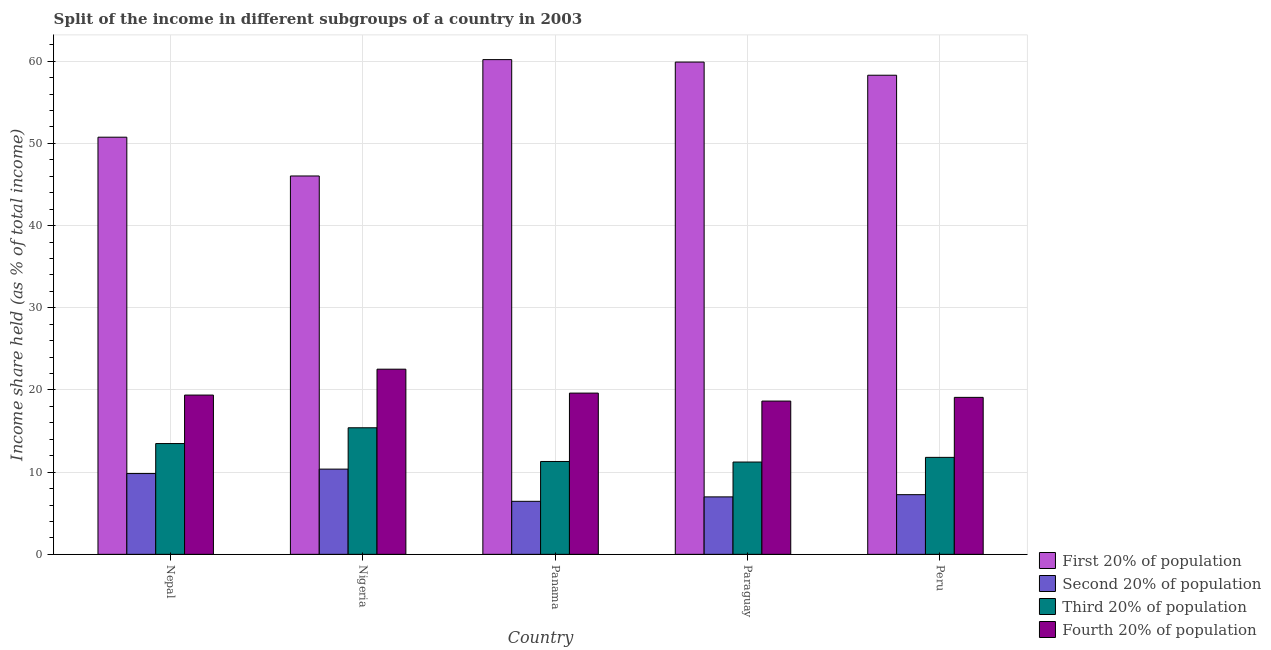How many different coloured bars are there?
Make the answer very short. 4. How many groups of bars are there?
Make the answer very short. 5. Are the number of bars per tick equal to the number of legend labels?
Keep it short and to the point. Yes. What is the label of the 5th group of bars from the left?
Give a very brief answer. Peru. What is the share of the income held by first 20% of the population in Paraguay?
Ensure brevity in your answer.  59.9. Across all countries, what is the maximum share of the income held by third 20% of the population?
Offer a very short reply. 15.4. Across all countries, what is the minimum share of the income held by third 20% of the population?
Keep it short and to the point. 11.23. In which country was the share of the income held by second 20% of the population maximum?
Keep it short and to the point. Nigeria. In which country was the share of the income held by first 20% of the population minimum?
Provide a succinct answer. Nigeria. What is the total share of the income held by fourth 20% of the population in the graph?
Make the answer very short. 99.28. What is the difference between the share of the income held by second 20% of the population in Nigeria and that in Peru?
Ensure brevity in your answer.  3.11. What is the difference between the share of the income held by third 20% of the population in Paraguay and the share of the income held by fourth 20% of the population in Nepal?
Offer a terse response. -8.15. What is the average share of the income held by first 20% of the population per country?
Offer a very short reply. 55.04. What is the difference between the share of the income held by first 20% of the population and share of the income held by fourth 20% of the population in Paraguay?
Provide a short and direct response. 41.25. What is the ratio of the share of the income held by third 20% of the population in Panama to that in Peru?
Make the answer very short. 0.96. What is the difference between the highest and the second highest share of the income held by first 20% of the population?
Your response must be concise. 0.3. What is the difference between the highest and the lowest share of the income held by second 20% of the population?
Offer a very short reply. 3.92. In how many countries, is the share of the income held by fourth 20% of the population greater than the average share of the income held by fourth 20% of the population taken over all countries?
Ensure brevity in your answer.  1. Is the sum of the share of the income held by third 20% of the population in Panama and Paraguay greater than the maximum share of the income held by first 20% of the population across all countries?
Provide a short and direct response. No. What does the 3rd bar from the left in Paraguay represents?
Offer a very short reply. Third 20% of population. What does the 1st bar from the right in Panama represents?
Your response must be concise. Fourth 20% of population. How many bars are there?
Give a very brief answer. 20. How many countries are there in the graph?
Give a very brief answer. 5. Are the values on the major ticks of Y-axis written in scientific E-notation?
Offer a terse response. No. Does the graph contain any zero values?
Offer a terse response. No. Where does the legend appear in the graph?
Ensure brevity in your answer.  Bottom right. How are the legend labels stacked?
Your response must be concise. Vertical. What is the title of the graph?
Offer a very short reply. Split of the income in different subgroups of a country in 2003. What is the label or title of the X-axis?
Provide a succinct answer. Country. What is the label or title of the Y-axis?
Ensure brevity in your answer.  Income share held (as % of total income). What is the Income share held (as % of total income) in First 20% of population in Nepal?
Your answer should be compact. 50.76. What is the Income share held (as % of total income) of Second 20% of population in Nepal?
Ensure brevity in your answer.  9.83. What is the Income share held (as % of total income) of Third 20% of population in Nepal?
Keep it short and to the point. 13.48. What is the Income share held (as % of total income) in Fourth 20% of population in Nepal?
Provide a short and direct response. 19.38. What is the Income share held (as % of total income) in First 20% of population in Nigeria?
Offer a very short reply. 46.04. What is the Income share held (as % of total income) in Second 20% of population in Nigeria?
Make the answer very short. 10.37. What is the Income share held (as % of total income) of Third 20% of population in Nigeria?
Provide a succinct answer. 15.4. What is the Income share held (as % of total income) in Fourth 20% of population in Nigeria?
Make the answer very short. 22.53. What is the Income share held (as % of total income) of First 20% of population in Panama?
Give a very brief answer. 60.2. What is the Income share held (as % of total income) in Second 20% of population in Panama?
Your answer should be very brief. 6.45. What is the Income share held (as % of total income) of Third 20% of population in Panama?
Keep it short and to the point. 11.3. What is the Income share held (as % of total income) in Fourth 20% of population in Panama?
Keep it short and to the point. 19.62. What is the Income share held (as % of total income) of First 20% of population in Paraguay?
Offer a terse response. 59.9. What is the Income share held (as % of total income) in Second 20% of population in Paraguay?
Your answer should be very brief. 6.99. What is the Income share held (as % of total income) of Third 20% of population in Paraguay?
Your response must be concise. 11.23. What is the Income share held (as % of total income) of Fourth 20% of population in Paraguay?
Provide a succinct answer. 18.65. What is the Income share held (as % of total income) of First 20% of population in Peru?
Provide a succinct answer. 58.3. What is the Income share held (as % of total income) in Second 20% of population in Peru?
Your response must be concise. 7.26. What is the Income share held (as % of total income) in Third 20% of population in Peru?
Provide a short and direct response. 11.8. What is the Income share held (as % of total income) in Fourth 20% of population in Peru?
Make the answer very short. 19.1. Across all countries, what is the maximum Income share held (as % of total income) of First 20% of population?
Offer a terse response. 60.2. Across all countries, what is the maximum Income share held (as % of total income) in Second 20% of population?
Your response must be concise. 10.37. Across all countries, what is the maximum Income share held (as % of total income) of Fourth 20% of population?
Offer a terse response. 22.53. Across all countries, what is the minimum Income share held (as % of total income) in First 20% of population?
Offer a very short reply. 46.04. Across all countries, what is the minimum Income share held (as % of total income) of Second 20% of population?
Your answer should be very brief. 6.45. Across all countries, what is the minimum Income share held (as % of total income) in Third 20% of population?
Ensure brevity in your answer.  11.23. Across all countries, what is the minimum Income share held (as % of total income) in Fourth 20% of population?
Provide a succinct answer. 18.65. What is the total Income share held (as % of total income) of First 20% of population in the graph?
Provide a succinct answer. 275.2. What is the total Income share held (as % of total income) in Second 20% of population in the graph?
Your response must be concise. 40.9. What is the total Income share held (as % of total income) of Third 20% of population in the graph?
Your answer should be compact. 63.21. What is the total Income share held (as % of total income) of Fourth 20% of population in the graph?
Provide a short and direct response. 99.28. What is the difference between the Income share held (as % of total income) of First 20% of population in Nepal and that in Nigeria?
Make the answer very short. 4.72. What is the difference between the Income share held (as % of total income) in Second 20% of population in Nepal and that in Nigeria?
Ensure brevity in your answer.  -0.54. What is the difference between the Income share held (as % of total income) of Third 20% of population in Nepal and that in Nigeria?
Offer a terse response. -1.92. What is the difference between the Income share held (as % of total income) of Fourth 20% of population in Nepal and that in Nigeria?
Provide a short and direct response. -3.15. What is the difference between the Income share held (as % of total income) in First 20% of population in Nepal and that in Panama?
Give a very brief answer. -9.44. What is the difference between the Income share held (as % of total income) of Second 20% of population in Nepal and that in Panama?
Your response must be concise. 3.38. What is the difference between the Income share held (as % of total income) in Third 20% of population in Nepal and that in Panama?
Give a very brief answer. 2.18. What is the difference between the Income share held (as % of total income) of Fourth 20% of population in Nepal and that in Panama?
Ensure brevity in your answer.  -0.24. What is the difference between the Income share held (as % of total income) of First 20% of population in Nepal and that in Paraguay?
Provide a short and direct response. -9.14. What is the difference between the Income share held (as % of total income) of Second 20% of population in Nepal and that in Paraguay?
Your answer should be compact. 2.84. What is the difference between the Income share held (as % of total income) of Third 20% of population in Nepal and that in Paraguay?
Provide a short and direct response. 2.25. What is the difference between the Income share held (as % of total income) in Fourth 20% of population in Nepal and that in Paraguay?
Your answer should be very brief. 0.73. What is the difference between the Income share held (as % of total income) of First 20% of population in Nepal and that in Peru?
Ensure brevity in your answer.  -7.54. What is the difference between the Income share held (as % of total income) in Second 20% of population in Nepal and that in Peru?
Make the answer very short. 2.57. What is the difference between the Income share held (as % of total income) in Third 20% of population in Nepal and that in Peru?
Make the answer very short. 1.68. What is the difference between the Income share held (as % of total income) of Fourth 20% of population in Nepal and that in Peru?
Give a very brief answer. 0.28. What is the difference between the Income share held (as % of total income) in First 20% of population in Nigeria and that in Panama?
Offer a very short reply. -14.16. What is the difference between the Income share held (as % of total income) in Second 20% of population in Nigeria and that in Panama?
Keep it short and to the point. 3.92. What is the difference between the Income share held (as % of total income) in Fourth 20% of population in Nigeria and that in Panama?
Keep it short and to the point. 2.91. What is the difference between the Income share held (as % of total income) of First 20% of population in Nigeria and that in Paraguay?
Offer a terse response. -13.86. What is the difference between the Income share held (as % of total income) in Second 20% of population in Nigeria and that in Paraguay?
Keep it short and to the point. 3.38. What is the difference between the Income share held (as % of total income) in Third 20% of population in Nigeria and that in Paraguay?
Your answer should be very brief. 4.17. What is the difference between the Income share held (as % of total income) in Fourth 20% of population in Nigeria and that in Paraguay?
Provide a short and direct response. 3.88. What is the difference between the Income share held (as % of total income) of First 20% of population in Nigeria and that in Peru?
Your response must be concise. -12.26. What is the difference between the Income share held (as % of total income) in Second 20% of population in Nigeria and that in Peru?
Offer a terse response. 3.11. What is the difference between the Income share held (as % of total income) of Fourth 20% of population in Nigeria and that in Peru?
Your response must be concise. 3.43. What is the difference between the Income share held (as % of total income) in Second 20% of population in Panama and that in Paraguay?
Give a very brief answer. -0.54. What is the difference between the Income share held (as % of total income) of Third 20% of population in Panama and that in Paraguay?
Your answer should be compact. 0.07. What is the difference between the Income share held (as % of total income) of Second 20% of population in Panama and that in Peru?
Your answer should be very brief. -0.81. What is the difference between the Income share held (as % of total income) of Fourth 20% of population in Panama and that in Peru?
Ensure brevity in your answer.  0.52. What is the difference between the Income share held (as % of total income) of Second 20% of population in Paraguay and that in Peru?
Offer a very short reply. -0.27. What is the difference between the Income share held (as % of total income) of Third 20% of population in Paraguay and that in Peru?
Offer a terse response. -0.57. What is the difference between the Income share held (as % of total income) in Fourth 20% of population in Paraguay and that in Peru?
Give a very brief answer. -0.45. What is the difference between the Income share held (as % of total income) of First 20% of population in Nepal and the Income share held (as % of total income) of Second 20% of population in Nigeria?
Offer a very short reply. 40.39. What is the difference between the Income share held (as % of total income) of First 20% of population in Nepal and the Income share held (as % of total income) of Third 20% of population in Nigeria?
Offer a very short reply. 35.36. What is the difference between the Income share held (as % of total income) in First 20% of population in Nepal and the Income share held (as % of total income) in Fourth 20% of population in Nigeria?
Make the answer very short. 28.23. What is the difference between the Income share held (as % of total income) of Second 20% of population in Nepal and the Income share held (as % of total income) of Third 20% of population in Nigeria?
Provide a short and direct response. -5.57. What is the difference between the Income share held (as % of total income) of Second 20% of population in Nepal and the Income share held (as % of total income) of Fourth 20% of population in Nigeria?
Your answer should be compact. -12.7. What is the difference between the Income share held (as % of total income) in Third 20% of population in Nepal and the Income share held (as % of total income) in Fourth 20% of population in Nigeria?
Give a very brief answer. -9.05. What is the difference between the Income share held (as % of total income) in First 20% of population in Nepal and the Income share held (as % of total income) in Second 20% of population in Panama?
Your response must be concise. 44.31. What is the difference between the Income share held (as % of total income) of First 20% of population in Nepal and the Income share held (as % of total income) of Third 20% of population in Panama?
Provide a short and direct response. 39.46. What is the difference between the Income share held (as % of total income) in First 20% of population in Nepal and the Income share held (as % of total income) in Fourth 20% of population in Panama?
Offer a very short reply. 31.14. What is the difference between the Income share held (as % of total income) of Second 20% of population in Nepal and the Income share held (as % of total income) of Third 20% of population in Panama?
Ensure brevity in your answer.  -1.47. What is the difference between the Income share held (as % of total income) in Second 20% of population in Nepal and the Income share held (as % of total income) in Fourth 20% of population in Panama?
Provide a succinct answer. -9.79. What is the difference between the Income share held (as % of total income) in Third 20% of population in Nepal and the Income share held (as % of total income) in Fourth 20% of population in Panama?
Your answer should be very brief. -6.14. What is the difference between the Income share held (as % of total income) of First 20% of population in Nepal and the Income share held (as % of total income) of Second 20% of population in Paraguay?
Keep it short and to the point. 43.77. What is the difference between the Income share held (as % of total income) in First 20% of population in Nepal and the Income share held (as % of total income) in Third 20% of population in Paraguay?
Your response must be concise. 39.53. What is the difference between the Income share held (as % of total income) of First 20% of population in Nepal and the Income share held (as % of total income) of Fourth 20% of population in Paraguay?
Provide a succinct answer. 32.11. What is the difference between the Income share held (as % of total income) of Second 20% of population in Nepal and the Income share held (as % of total income) of Fourth 20% of population in Paraguay?
Give a very brief answer. -8.82. What is the difference between the Income share held (as % of total income) of Third 20% of population in Nepal and the Income share held (as % of total income) of Fourth 20% of population in Paraguay?
Provide a short and direct response. -5.17. What is the difference between the Income share held (as % of total income) of First 20% of population in Nepal and the Income share held (as % of total income) of Second 20% of population in Peru?
Your answer should be compact. 43.5. What is the difference between the Income share held (as % of total income) in First 20% of population in Nepal and the Income share held (as % of total income) in Third 20% of population in Peru?
Offer a terse response. 38.96. What is the difference between the Income share held (as % of total income) of First 20% of population in Nepal and the Income share held (as % of total income) of Fourth 20% of population in Peru?
Offer a very short reply. 31.66. What is the difference between the Income share held (as % of total income) in Second 20% of population in Nepal and the Income share held (as % of total income) in Third 20% of population in Peru?
Keep it short and to the point. -1.97. What is the difference between the Income share held (as % of total income) in Second 20% of population in Nepal and the Income share held (as % of total income) in Fourth 20% of population in Peru?
Your response must be concise. -9.27. What is the difference between the Income share held (as % of total income) in Third 20% of population in Nepal and the Income share held (as % of total income) in Fourth 20% of population in Peru?
Offer a very short reply. -5.62. What is the difference between the Income share held (as % of total income) in First 20% of population in Nigeria and the Income share held (as % of total income) in Second 20% of population in Panama?
Your response must be concise. 39.59. What is the difference between the Income share held (as % of total income) of First 20% of population in Nigeria and the Income share held (as % of total income) of Third 20% of population in Panama?
Provide a succinct answer. 34.74. What is the difference between the Income share held (as % of total income) in First 20% of population in Nigeria and the Income share held (as % of total income) in Fourth 20% of population in Panama?
Offer a terse response. 26.42. What is the difference between the Income share held (as % of total income) in Second 20% of population in Nigeria and the Income share held (as % of total income) in Third 20% of population in Panama?
Your response must be concise. -0.93. What is the difference between the Income share held (as % of total income) of Second 20% of population in Nigeria and the Income share held (as % of total income) of Fourth 20% of population in Panama?
Provide a short and direct response. -9.25. What is the difference between the Income share held (as % of total income) of Third 20% of population in Nigeria and the Income share held (as % of total income) of Fourth 20% of population in Panama?
Provide a succinct answer. -4.22. What is the difference between the Income share held (as % of total income) in First 20% of population in Nigeria and the Income share held (as % of total income) in Second 20% of population in Paraguay?
Provide a succinct answer. 39.05. What is the difference between the Income share held (as % of total income) of First 20% of population in Nigeria and the Income share held (as % of total income) of Third 20% of population in Paraguay?
Offer a very short reply. 34.81. What is the difference between the Income share held (as % of total income) of First 20% of population in Nigeria and the Income share held (as % of total income) of Fourth 20% of population in Paraguay?
Provide a short and direct response. 27.39. What is the difference between the Income share held (as % of total income) of Second 20% of population in Nigeria and the Income share held (as % of total income) of Third 20% of population in Paraguay?
Offer a terse response. -0.86. What is the difference between the Income share held (as % of total income) in Second 20% of population in Nigeria and the Income share held (as % of total income) in Fourth 20% of population in Paraguay?
Keep it short and to the point. -8.28. What is the difference between the Income share held (as % of total income) of Third 20% of population in Nigeria and the Income share held (as % of total income) of Fourth 20% of population in Paraguay?
Make the answer very short. -3.25. What is the difference between the Income share held (as % of total income) of First 20% of population in Nigeria and the Income share held (as % of total income) of Second 20% of population in Peru?
Give a very brief answer. 38.78. What is the difference between the Income share held (as % of total income) of First 20% of population in Nigeria and the Income share held (as % of total income) of Third 20% of population in Peru?
Give a very brief answer. 34.24. What is the difference between the Income share held (as % of total income) in First 20% of population in Nigeria and the Income share held (as % of total income) in Fourth 20% of population in Peru?
Keep it short and to the point. 26.94. What is the difference between the Income share held (as % of total income) of Second 20% of population in Nigeria and the Income share held (as % of total income) of Third 20% of population in Peru?
Your answer should be very brief. -1.43. What is the difference between the Income share held (as % of total income) in Second 20% of population in Nigeria and the Income share held (as % of total income) in Fourth 20% of population in Peru?
Offer a terse response. -8.73. What is the difference between the Income share held (as % of total income) of First 20% of population in Panama and the Income share held (as % of total income) of Second 20% of population in Paraguay?
Provide a succinct answer. 53.21. What is the difference between the Income share held (as % of total income) in First 20% of population in Panama and the Income share held (as % of total income) in Third 20% of population in Paraguay?
Ensure brevity in your answer.  48.97. What is the difference between the Income share held (as % of total income) of First 20% of population in Panama and the Income share held (as % of total income) of Fourth 20% of population in Paraguay?
Provide a succinct answer. 41.55. What is the difference between the Income share held (as % of total income) in Second 20% of population in Panama and the Income share held (as % of total income) in Third 20% of population in Paraguay?
Give a very brief answer. -4.78. What is the difference between the Income share held (as % of total income) in Third 20% of population in Panama and the Income share held (as % of total income) in Fourth 20% of population in Paraguay?
Your response must be concise. -7.35. What is the difference between the Income share held (as % of total income) in First 20% of population in Panama and the Income share held (as % of total income) in Second 20% of population in Peru?
Offer a terse response. 52.94. What is the difference between the Income share held (as % of total income) in First 20% of population in Panama and the Income share held (as % of total income) in Third 20% of population in Peru?
Give a very brief answer. 48.4. What is the difference between the Income share held (as % of total income) in First 20% of population in Panama and the Income share held (as % of total income) in Fourth 20% of population in Peru?
Your response must be concise. 41.1. What is the difference between the Income share held (as % of total income) of Second 20% of population in Panama and the Income share held (as % of total income) of Third 20% of population in Peru?
Ensure brevity in your answer.  -5.35. What is the difference between the Income share held (as % of total income) of Second 20% of population in Panama and the Income share held (as % of total income) of Fourth 20% of population in Peru?
Your answer should be very brief. -12.65. What is the difference between the Income share held (as % of total income) in First 20% of population in Paraguay and the Income share held (as % of total income) in Second 20% of population in Peru?
Your answer should be compact. 52.64. What is the difference between the Income share held (as % of total income) in First 20% of population in Paraguay and the Income share held (as % of total income) in Third 20% of population in Peru?
Provide a succinct answer. 48.1. What is the difference between the Income share held (as % of total income) of First 20% of population in Paraguay and the Income share held (as % of total income) of Fourth 20% of population in Peru?
Your response must be concise. 40.8. What is the difference between the Income share held (as % of total income) in Second 20% of population in Paraguay and the Income share held (as % of total income) in Third 20% of population in Peru?
Give a very brief answer. -4.81. What is the difference between the Income share held (as % of total income) of Second 20% of population in Paraguay and the Income share held (as % of total income) of Fourth 20% of population in Peru?
Your answer should be very brief. -12.11. What is the difference between the Income share held (as % of total income) in Third 20% of population in Paraguay and the Income share held (as % of total income) in Fourth 20% of population in Peru?
Give a very brief answer. -7.87. What is the average Income share held (as % of total income) in First 20% of population per country?
Ensure brevity in your answer.  55.04. What is the average Income share held (as % of total income) in Second 20% of population per country?
Offer a terse response. 8.18. What is the average Income share held (as % of total income) in Third 20% of population per country?
Offer a very short reply. 12.64. What is the average Income share held (as % of total income) in Fourth 20% of population per country?
Ensure brevity in your answer.  19.86. What is the difference between the Income share held (as % of total income) in First 20% of population and Income share held (as % of total income) in Second 20% of population in Nepal?
Keep it short and to the point. 40.93. What is the difference between the Income share held (as % of total income) of First 20% of population and Income share held (as % of total income) of Third 20% of population in Nepal?
Your answer should be compact. 37.28. What is the difference between the Income share held (as % of total income) of First 20% of population and Income share held (as % of total income) of Fourth 20% of population in Nepal?
Keep it short and to the point. 31.38. What is the difference between the Income share held (as % of total income) in Second 20% of population and Income share held (as % of total income) in Third 20% of population in Nepal?
Give a very brief answer. -3.65. What is the difference between the Income share held (as % of total income) of Second 20% of population and Income share held (as % of total income) of Fourth 20% of population in Nepal?
Make the answer very short. -9.55. What is the difference between the Income share held (as % of total income) of Third 20% of population and Income share held (as % of total income) of Fourth 20% of population in Nepal?
Your answer should be compact. -5.9. What is the difference between the Income share held (as % of total income) in First 20% of population and Income share held (as % of total income) in Second 20% of population in Nigeria?
Ensure brevity in your answer.  35.67. What is the difference between the Income share held (as % of total income) in First 20% of population and Income share held (as % of total income) in Third 20% of population in Nigeria?
Ensure brevity in your answer.  30.64. What is the difference between the Income share held (as % of total income) of First 20% of population and Income share held (as % of total income) of Fourth 20% of population in Nigeria?
Your answer should be compact. 23.51. What is the difference between the Income share held (as % of total income) of Second 20% of population and Income share held (as % of total income) of Third 20% of population in Nigeria?
Ensure brevity in your answer.  -5.03. What is the difference between the Income share held (as % of total income) in Second 20% of population and Income share held (as % of total income) in Fourth 20% of population in Nigeria?
Your answer should be very brief. -12.16. What is the difference between the Income share held (as % of total income) in Third 20% of population and Income share held (as % of total income) in Fourth 20% of population in Nigeria?
Your response must be concise. -7.13. What is the difference between the Income share held (as % of total income) in First 20% of population and Income share held (as % of total income) in Second 20% of population in Panama?
Offer a terse response. 53.75. What is the difference between the Income share held (as % of total income) in First 20% of population and Income share held (as % of total income) in Third 20% of population in Panama?
Provide a short and direct response. 48.9. What is the difference between the Income share held (as % of total income) in First 20% of population and Income share held (as % of total income) in Fourth 20% of population in Panama?
Provide a short and direct response. 40.58. What is the difference between the Income share held (as % of total income) of Second 20% of population and Income share held (as % of total income) of Third 20% of population in Panama?
Your answer should be compact. -4.85. What is the difference between the Income share held (as % of total income) of Second 20% of population and Income share held (as % of total income) of Fourth 20% of population in Panama?
Your answer should be very brief. -13.17. What is the difference between the Income share held (as % of total income) of Third 20% of population and Income share held (as % of total income) of Fourth 20% of population in Panama?
Provide a succinct answer. -8.32. What is the difference between the Income share held (as % of total income) of First 20% of population and Income share held (as % of total income) of Second 20% of population in Paraguay?
Provide a short and direct response. 52.91. What is the difference between the Income share held (as % of total income) in First 20% of population and Income share held (as % of total income) in Third 20% of population in Paraguay?
Offer a very short reply. 48.67. What is the difference between the Income share held (as % of total income) in First 20% of population and Income share held (as % of total income) in Fourth 20% of population in Paraguay?
Provide a succinct answer. 41.25. What is the difference between the Income share held (as % of total income) in Second 20% of population and Income share held (as % of total income) in Third 20% of population in Paraguay?
Give a very brief answer. -4.24. What is the difference between the Income share held (as % of total income) of Second 20% of population and Income share held (as % of total income) of Fourth 20% of population in Paraguay?
Give a very brief answer. -11.66. What is the difference between the Income share held (as % of total income) of Third 20% of population and Income share held (as % of total income) of Fourth 20% of population in Paraguay?
Provide a succinct answer. -7.42. What is the difference between the Income share held (as % of total income) in First 20% of population and Income share held (as % of total income) in Second 20% of population in Peru?
Your response must be concise. 51.04. What is the difference between the Income share held (as % of total income) in First 20% of population and Income share held (as % of total income) in Third 20% of population in Peru?
Your response must be concise. 46.5. What is the difference between the Income share held (as % of total income) of First 20% of population and Income share held (as % of total income) of Fourth 20% of population in Peru?
Make the answer very short. 39.2. What is the difference between the Income share held (as % of total income) in Second 20% of population and Income share held (as % of total income) in Third 20% of population in Peru?
Provide a succinct answer. -4.54. What is the difference between the Income share held (as % of total income) in Second 20% of population and Income share held (as % of total income) in Fourth 20% of population in Peru?
Make the answer very short. -11.84. What is the ratio of the Income share held (as % of total income) of First 20% of population in Nepal to that in Nigeria?
Provide a short and direct response. 1.1. What is the ratio of the Income share held (as % of total income) of Second 20% of population in Nepal to that in Nigeria?
Your answer should be compact. 0.95. What is the ratio of the Income share held (as % of total income) of Third 20% of population in Nepal to that in Nigeria?
Your answer should be compact. 0.88. What is the ratio of the Income share held (as % of total income) of Fourth 20% of population in Nepal to that in Nigeria?
Make the answer very short. 0.86. What is the ratio of the Income share held (as % of total income) of First 20% of population in Nepal to that in Panama?
Offer a very short reply. 0.84. What is the ratio of the Income share held (as % of total income) in Second 20% of population in Nepal to that in Panama?
Ensure brevity in your answer.  1.52. What is the ratio of the Income share held (as % of total income) in Third 20% of population in Nepal to that in Panama?
Offer a very short reply. 1.19. What is the ratio of the Income share held (as % of total income) in First 20% of population in Nepal to that in Paraguay?
Provide a succinct answer. 0.85. What is the ratio of the Income share held (as % of total income) in Second 20% of population in Nepal to that in Paraguay?
Your response must be concise. 1.41. What is the ratio of the Income share held (as % of total income) of Third 20% of population in Nepal to that in Paraguay?
Give a very brief answer. 1.2. What is the ratio of the Income share held (as % of total income) of Fourth 20% of population in Nepal to that in Paraguay?
Give a very brief answer. 1.04. What is the ratio of the Income share held (as % of total income) in First 20% of population in Nepal to that in Peru?
Provide a short and direct response. 0.87. What is the ratio of the Income share held (as % of total income) in Second 20% of population in Nepal to that in Peru?
Your answer should be compact. 1.35. What is the ratio of the Income share held (as % of total income) in Third 20% of population in Nepal to that in Peru?
Make the answer very short. 1.14. What is the ratio of the Income share held (as % of total income) of Fourth 20% of population in Nepal to that in Peru?
Keep it short and to the point. 1.01. What is the ratio of the Income share held (as % of total income) in First 20% of population in Nigeria to that in Panama?
Give a very brief answer. 0.76. What is the ratio of the Income share held (as % of total income) of Second 20% of population in Nigeria to that in Panama?
Offer a very short reply. 1.61. What is the ratio of the Income share held (as % of total income) in Third 20% of population in Nigeria to that in Panama?
Provide a succinct answer. 1.36. What is the ratio of the Income share held (as % of total income) in Fourth 20% of population in Nigeria to that in Panama?
Your answer should be very brief. 1.15. What is the ratio of the Income share held (as % of total income) of First 20% of population in Nigeria to that in Paraguay?
Provide a short and direct response. 0.77. What is the ratio of the Income share held (as % of total income) of Second 20% of population in Nigeria to that in Paraguay?
Offer a terse response. 1.48. What is the ratio of the Income share held (as % of total income) in Third 20% of population in Nigeria to that in Paraguay?
Keep it short and to the point. 1.37. What is the ratio of the Income share held (as % of total income) of Fourth 20% of population in Nigeria to that in Paraguay?
Give a very brief answer. 1.21. What is the ratio of the Income share held (as % of total income) in First 20% of population in Nigeria to that in Peru?
Provide a succinct answer. 0.79. What is the ratio of the Income share held (as % of total income) in Second 20% of population in Nigeria to that in Peru?
Make the answer very short. 1.43. What is the ratio of the Income share held (as % of total income) in Third 20% of population in Nigeria to that in Peru?
Ensure brevity in your answer.  1.31. What is the ratio of the Income share held (as % of total income) in Fourth 20% of population in Nigeria to that in Peru?
Make the answer very short. 1.18. What is the ratio of the Income share held (as % of total income) in Second 20% of population in Panama to that in Paraguay?
Offer a very short reply. 0.92. What is the ratio of the Income share held (as % of total income) in Fourth 20% of population in Panama to that in Paraguay?
Make the answer very short. 1.05. What is the ratio of the Income share held (as % of total income) of First 20% of population in Panama to that in Peru?
Provide a short and direct response. 1.03. What is the ratio of the Income share held (as % of total income) of Second 20% of population in Panama to that in Peru?
Your answer should be compact. 0.89. What is the ratio of the Income share held (as % of total income) of Third 20% of population in Panama to that in Peru?
Your answer should be very brief. 0.96. What is the ratio of the Income share held (as % of total income) of Fourth 20% of population in Panama to that in Peru?
Your answer should be very brief. 1.03. What is the ratio of the Income share held (as % of total income) of First 20% of population in Paraguay to that in Peru?
Your response must be concise. 1.03. What is the ratio of the Income share held (as % of total income) in Second 20% of population in Paraguay to that in Peru?
Give a very brief answer. 0.96. What is the ratio of the Income share held (as % of total income) of Third 20% of population in Paraguay to that in Peru?
Keep it short and to the point. 0.95. What is the ratio of the Income share held (as % of total income) in Fourth 20% of population in Paraguay to that in Peru?
Your answer should be compact. 0.98. What is the difference between the highest and the second highest Income share held (as % of total income) in First 20% of population?
Offer a very short reply. 0.3. What is the difference between the highest and the second highest Income share held (as % of total income) in Second 20% of population?
Provide a short and direct response. 0.54. What is the difference between the highest and the second highest Income share held (as % of total income) of Third 20% of population?
Your answer should be very brief. 1.92. What is the difference between the highest and the second highest Income share held (as % of total income) of Fourth 20% of population?
Your answer should be compact. 2.91. What is the difference between the highest and the lowest Income share held (as % of total income) of First 20% of population?
Provide a succinct answer. 14.16. What is the difference between the highest and the lowest Income share held (as % of total income) of Second 20% of population?
Offer a terse response. 3.92. What is the difference between the highest and the lowest Income share held (as % of total income) of Third 20% of population?
Offer a very short reply. 4.17. What is the difference between the highest and the lowest Income share held (as % of total income) in Fourth 20% of population?
Offer a terse response. 3.88. 